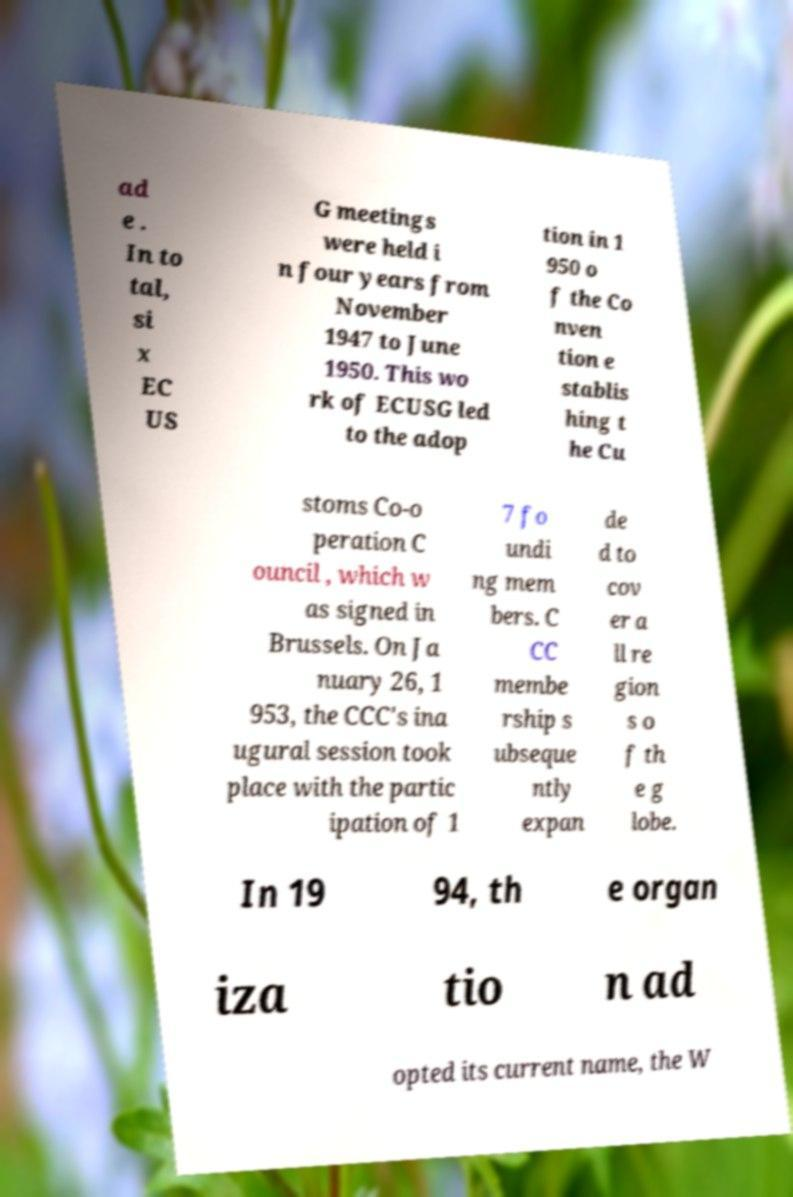Can you read and provide the text displayed in the image?This photo seems to have some interesting text. Can you extract and type it out for me? ad e . In to tal, si x EC US G meetings were held i n four years from November 1947 to June 1950. This wo rk of ECUSG led to the adop tion in 1 950 o f the Co nven tion e stablis hing t he Cu stoms Co-o peration C ouncil , which w as signed in Brussels. On Ja nuary 26, 1 953, the CCC's ina ugural session took place with the partic ipation of 1 7 fo undi ng mem bers. C CC membe rship s ubseque ntly expan de d to cov er a ll re gion s o f th e g lobe. In 19 94, th e organ iza tio n ad opted its current name, the W 